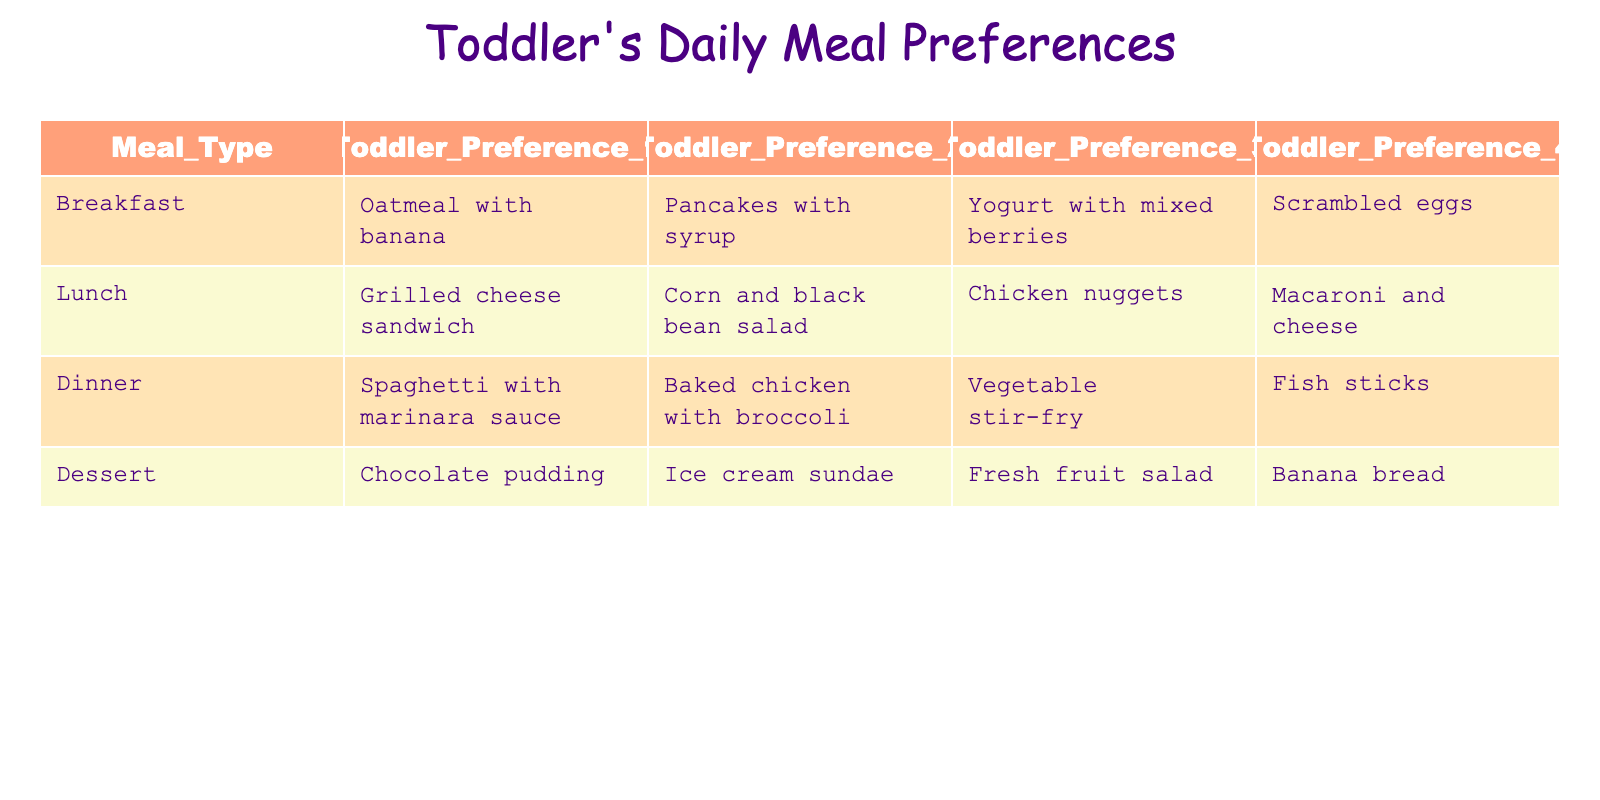What are the top 2 breakfast preferences for the toddler? The top 2 breakfast preferences can be found in the "Breakfast" row. They are "Oatmeal with banana" as the first preference and "Pancakes with syrup" as the second preference.
Answer: Oatmeal with banana, Pancakes with syrup How many different types of lunch options are listed? The table contains four lunch options in the "Lunch" row: "Grilled cheese sandwich," "Corn and black bean salad," "Chicken nuggets," and "Macaroni and cheese." So, there are four different types.
Answer: 4 Is "Fish sticks" one of the dinner preferences? "Fish sticks" is listed under the "Dinner" row as one of the preferences, indicating that it is indeed a preferred dinner option for the toddler.
Answer: Yes What is the toddler's least preferred dessert? To determine the least preferred dessert, we can refer to the "Dessert" row. "Banana bread" is the fourth preference, indicating it is the least preferred option among the listed desserts.
Answer: Banana bread If the top lunch preference was combined with the top dessert preference, what would it be? The top lunch preference is "Grilled cheese sandwich" and the top dessert preference is "Chocolate pudding." Combining these gives us "Grilled cheese sandwich and chocolate pudding."
Answer: Grilled cheese sandwich and chocolate pudding What are the toddler's preferences for lunch that don't include meat? The lunch options that do not include meat are "Grilled cheese sandwich" and "Corn and black bean salad." Therefore, these are the preferences without meat.
Answer: Grilled cheese sandwich, Corn and black bean salad What dessert option scores higher: "Ice cream sundae" or "Fresh fruit salad"? Since both "Ice cream sundae" and "Fresh fruit salad" are second and third preferences respectively in the dessert category, "Ice cream sundae" scores higher than "Fresh fruit salad" as the second preference is better than the third.
Answer: Ice cream sundae Which meal type has the most options listed? Analyzing the table, all meal types have four options listed, making it equal across breakfast, lunch, dinner, and dessert. Therefore, no meal type has more options than others.
Answer: All meal types have the same number of options (4) 